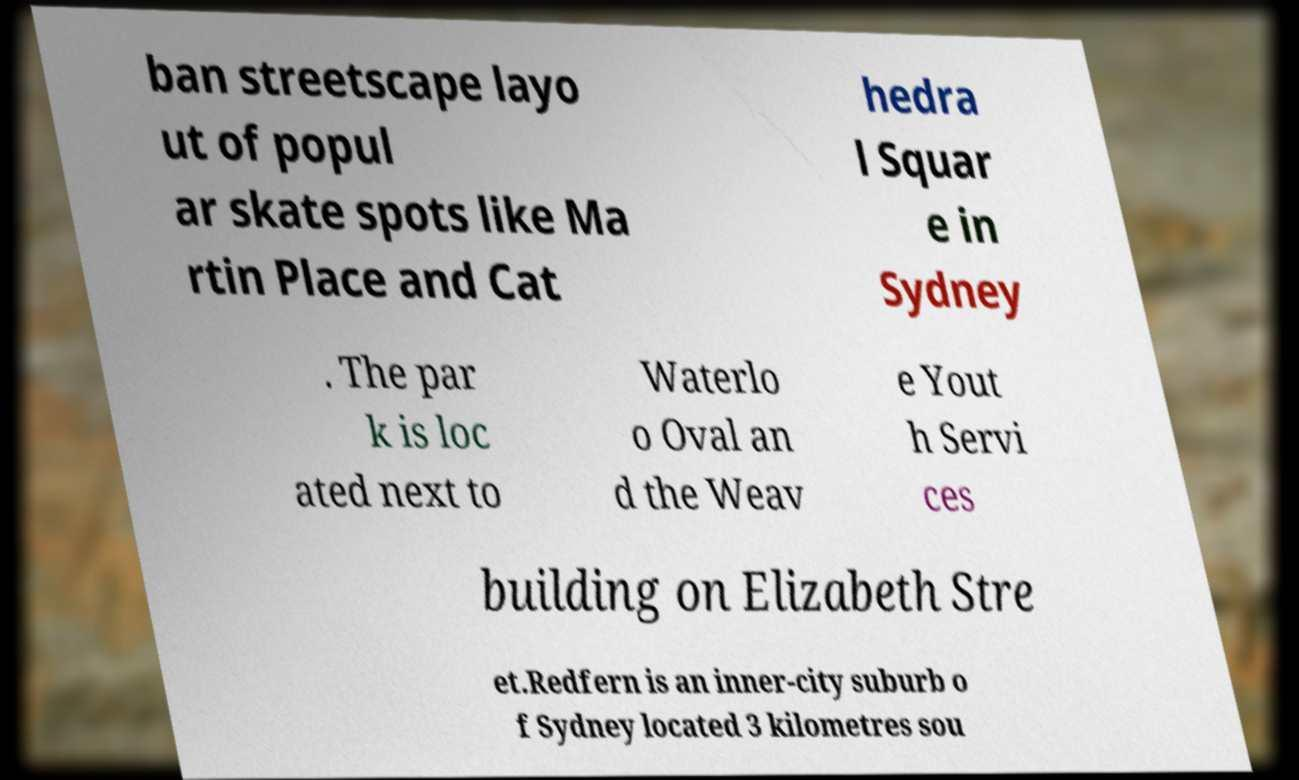There's text embedded in this image that I need extracted. Can you transcribe it verbatim? ban streetscape layo ut of popul ar skate spots like Ma rtin Place and Cat hedra l Squar e in Sydney . The par k is loc ated next to Waterlo o Oval an d the Weav e Yout h Servi ces building on Elizabeth Stre et.Redfern is an inner-city suburb o f Sydney located 3 kilometres sou 